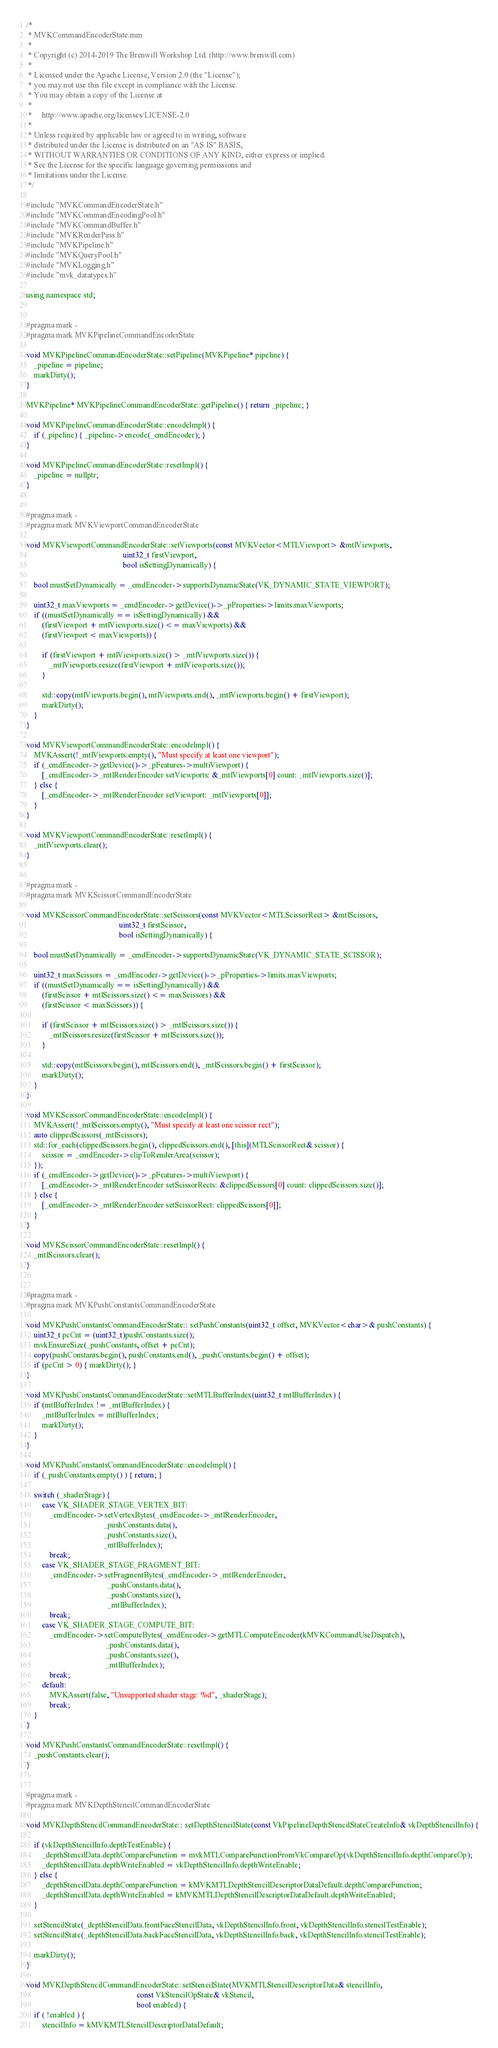<code> <loc_0><loc_0><loc_500><loc_500><_ObjectiveC_>/*
 * MVKCommandEncoderState.mm
 *
 * Copyright (c) 2014-2019 The Brenwill Workshop Ltd. (http://www.brenwill.com)
 *
 * Licensed under the Apache License, Version 2.0 (the "License");
 * you may not use this file except in compliance with the License.
 * You may obtain a copy of the License at
 * 
 *     http://www.apache.org/licenses/LICENSE-2.0
 * 
 * Unless required by applicable law or agreed to in writing, software
 * distributed under the License is distributed on an "AS IS" BASIS,
 * WITHOUT WARRANTIES OR CONDITIONS OF ANY KIND, either express or implied.
 * See the License for the specific language governing permissions and
 * limitations under the License.
 */

#include "MVKCommandEncoderState.h"
#include "MVKCommandEncodingPool.h"
#include "MVKCommandBuffer.h"
#include "MVKRenderPass.h"
#include "MVKPipeline.h"
#include "MVKQueryPool.h"
#include "MVKLogging.h"
#include "mvk_datatypes.h"

using namespace std;


#pragma mark -
#pragma mark MVKPipelineCommandEncoderState

void MVKPipelineCommandEncoderState::setPipeline(MVKPipeline* pipeline) {
    _pipeline = pipeline;
    markDirty();
}

MVKPipeline* MVKPipelineCommandEncoderState::getPipeline() { return _pipeline; }

void MVKPipelineCommandEncoderState::encodeImpl() {
    if (_pipeline) { _pipeline->encode(_cmdEncoder); }
}

void MVKPipelineCommandEncoderState::resetImpl() {
    _pipeline = nullptr;
}


#pragma mark -
#pragma mark MVKViewportCommandEncoderState

void MVKViewportCommandEncoderState::setViewports(const MVKVector<MTLViewport> &mtlViewports,
												  uint32_t firstViewport,
												  bool isSettingDynamically) {

	bool mustSetDynamically = _cmdEncoder->supportsDynamicState(VK_DYNAMIC_STATE_VIEWPORT);

	uint32_t maxViewports = _cmdEncoder->getDevice()->_pProperties->limits.maxViewports;
	if ((mustSetDynamically == isSettingDynamically) &&
		(firstViewport + mtlViewports.size() <= maxViewports) &&
		(firstViewport < maxViewports)) {

		if (firstViewport + mtlViewports.size() > _mtlViewports.size()) {
			_mtlViewports.resize(firstViewport + mtlViewports.size());
		}

		std::copy(mtlViewports.begin(), mtlViewports.end(), _mtlViewports.begin() + firstViewport);
		markDirty();
	}
}

void MVKViewportCommandEncoderState::encodeImpl() {
    MVKAssert(!_mtlViewports.empty(), "Must specify at least one viewport");
    if (_cmdEncoder->getDevice()->_pFeatures->multiViewport) {
        [_cmdEncoder->_mtlRenderEncoder setViewports: &_mtlViewports[0] count: _mtlViewports.size()];
    } else {
        [_cmdEncoder->_mtlRenderEncoder setViewport: _mtlViewports[0]];
    }
}

void MVKViewportCommandEncoderState::resetImpl() {
    _mtlViewports.clear();
}


#pragma mark -
#pragma mark MVKScissorCommandEncoderState

void MVKScissorCommandEncoderState::setScissors(const MVKVector<MTLScissorRect> &mtlScissors,
                                                uint32_t firstScissor,
												bool isSettingDynamically) {

	bool mustSetDynamically = _cmdEncoder->supportsDynamicState(VK_DYNAMIC_STATE_SCISSOR);

	uint32_t maxScissors = _cmdEncoder->getDevice()->_pProperties->limits.maxViewports;
	if ((mustSetDynamically == isSettingDynamically) &&
		(firstScissor + mtlScissors.size() <= maxScissors) &&
		(firstScissor < maxScissors)) {

		if (firstScissor + mtlScissors.size() > _mtlScissors.size()) {
			_mtlScissors.resize(firstScissor + mtlScissors.size());
		}

		std::copy(mtlScissors.begin(), mtlScissors.end(), _mtlScissors.begin() + firstScissor);
		markDirty();
	}
}

void MVKScissorCommandEncoderState::encodeImpl() {
	MVKAssert(!_mtlScissors.empty(), "Must specify at least one scissor rect");
	auto clippedScissors(_mtlScissors);
	std::for_each(clippedScissors.begin(), clippedScissors.end(), [this](MTLScissorRect& scissor) {
		scissor = _cmdEncoder->clipToRenderArea(scissor);
	});
	if (_cmdEncoder->getDevice()->_pFeatures->multiViewport) {
		[_cmdEncoder->_mtlRenderEncoder setScissorRects: &clippedScissors[0] count: clippedScissors.size()];
	} else {
		[_cmdEncoder->_mtlRenderEncoder setScissorRect: clippedScissors[0]];
	}
}

void MVKScissorCommandEncoderState::resetImpl() {
    _mtlScissors.clear();
}


#pragma mark -
#pragma mark MVKPushConstantsCommandEncoderState

void MVKPushConstantsCommandEncoderState:: setPushConstants(uint32_t offset, MVKVector<char>& pushConstants) {
    uint32_t pcCnt = (uint32_t)pushConstants.size();
    mvkEnsureSize(_pushConstants, offset + pcCnt);
    copy(pushConstants.begin(), pushConstants.end(), _pushConstants.begin() + offset);
    if (pcCnt > 0) { markDirty(); }
}

void MVKPushConstantsCommandEncoderState::setMTLBufferIndex(uint32_t mtlBufferIndex) {
    if (mtlBufferIndex != _mtlBufferIndex) {
        _mtlBufferIndex = mtlBufferIndex;
        markDirty();
    }
}

void MVKPushConstantsCommandEncoderState::encodeImpl() {
    if (_pushConstants.empty() ) { return; }

    switch (_shaderStage) {
        case VK_SHADER_STAGE_VERTEX_BIT:
            _cmdEncoder->setVertexBytes(_cmdEncoder->_mtlRenderEncoder,
                                        _pushConstants.data(),
                                        _pushConstants.size(),
                                        _mtlBufferIndex);
            break;
        case VK_SHADER_STAGE_FRAGMENT_BIT:
            _cmdEncoder->setFragmentBytes(_cmdEncoder->_mtlRenderEncoder,
                                          _pushConstants.data(),
                                          _pushConstants.size(),
                                          _mtlBufferIndex);
            break;
        case VK_SHADER_STAGE_COMPUTE_BIT:
            _cmdEncoder->setComputeBytes(_cmdEncoder->getMTLComputeEncoder(kMVKCommandUseDispatch),
                                         _pushConstants.data(),
                                         _pushConstants.size(),
                                         _mtlBufferIndex);
            break;
        default:
            MVKAssert(false, "Unsupported shader stage: %d", _shaderStage);
            break;
    }
}

void MVKPushConstantsCommandEncoderState::resetImpl() {
    _pushConstants.clear();
}


#pragma mark -
#pragma mark MVKDepthStencilCommandEncoderState

void MVKDepthStencilCommandEncoderState:: setDepthStencilState(const VkPipelineDepthStencilStateCreateInfo& vkDepthStencilInfo) {

    if (vkDepthStencilInfo.depthTestEnable) {
        _depthStencilData.depthCompareFunction = mvkMTLCompareFunctionFromVkCompareOp(vkDepthStencilInfo.depthCompareOp);
        _depthStencilData.depthWriteEnabled = vkDepthStencilInfo.depthWriteEnable;
    } else {
        _depthStencilData.depthCompareFunction = kMVKMTLDepthStencilDescriptorDataDefault.depthCompareFunction;
        _depthStencilData.depthWriteEnabled = kMVKMTLDepthStencilDescriptorDataDefault.depthWriteEnabled;
    }

    setStencilState(_depthStencilData.frontFaceStencilData, vkDepthStencilInfo.front, vkDepthStencilInfo.stencilTestEnable);
    setStencilState(_depthStencilData.backFaceStencilData, vkDepthStencilInfo.back, vkDepthStencilInfo.stencilTestEnable);

    markDirty();
}

void MVKDepthStencilCommandEncoderState::setStencilState(MVKMTLStencilDescriptorData& stencilInfo,
                                                         const VkStencilOpState& vkStencil,
                                                         bool enabled) {
    if ( !enabled ) {
        stencilInfo = kMVKMTLStencilDescriptorDataDefault;</code> 